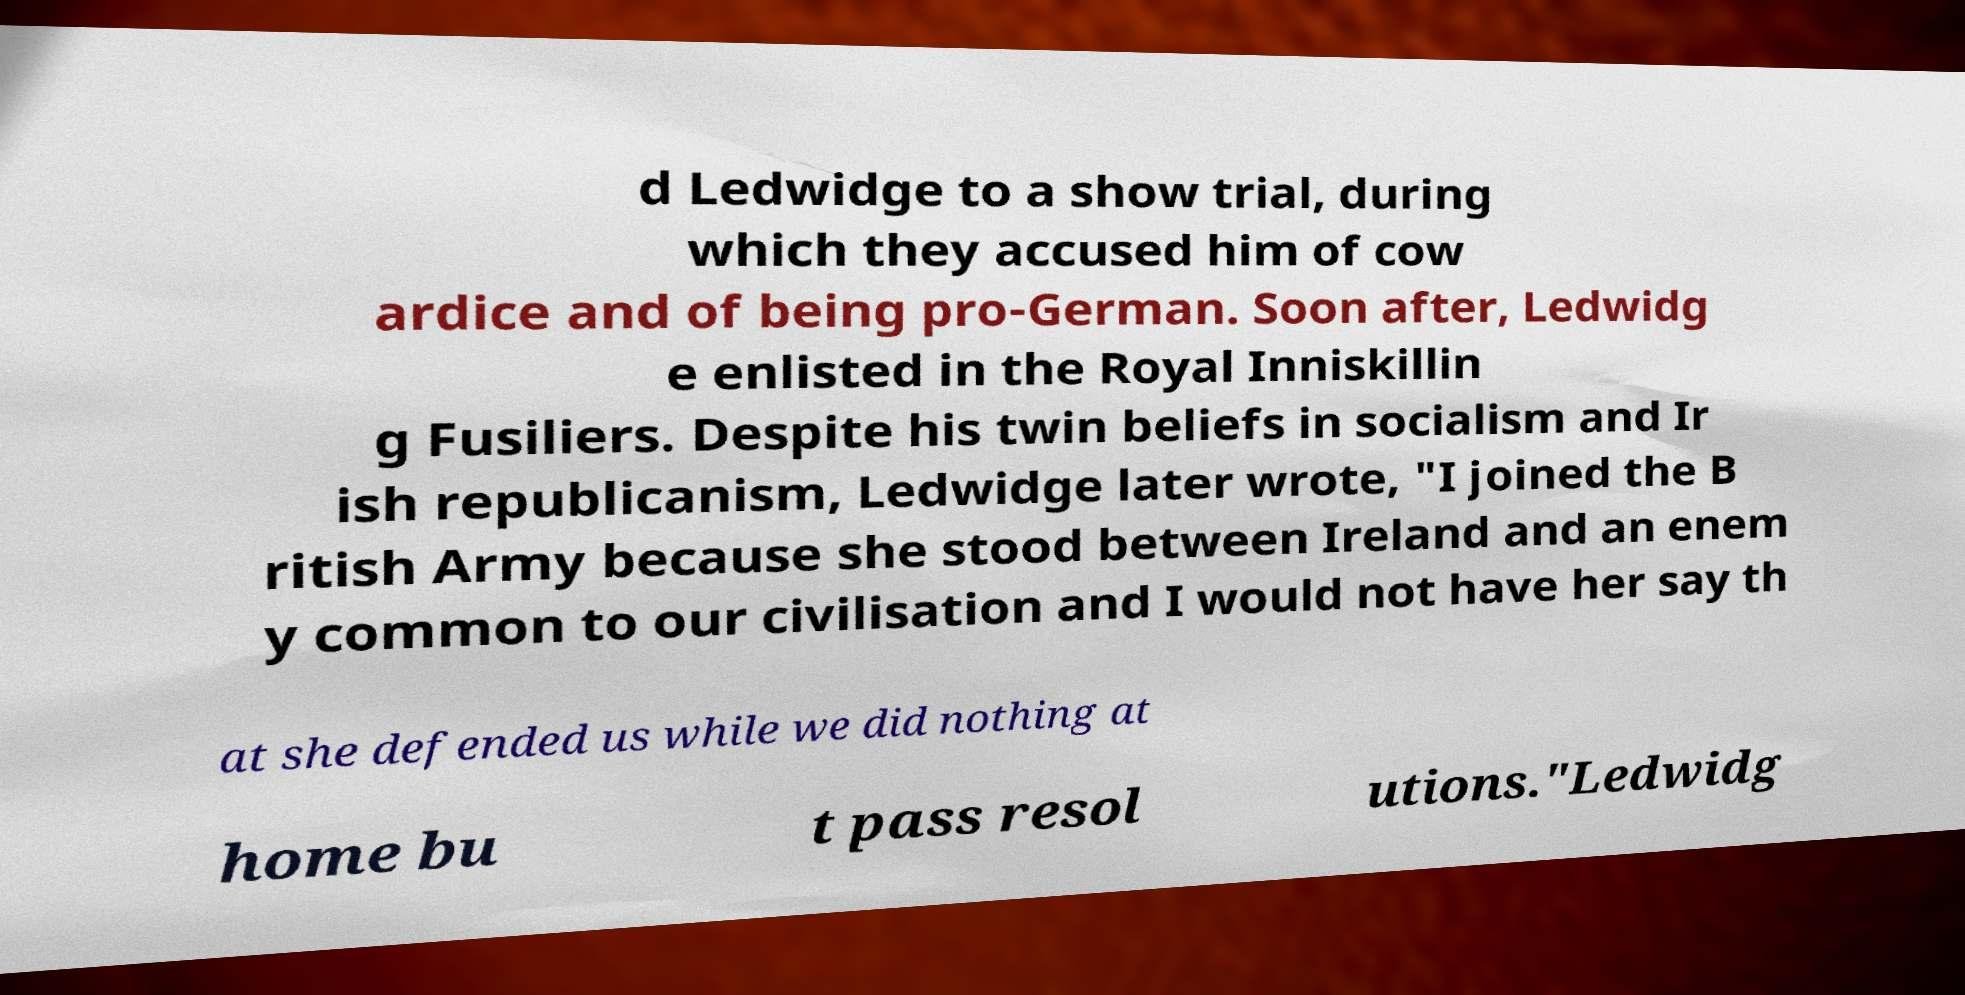Can you read and provide the text displayed in the image?This photo seems to have some interesting text. Can you extract and type it out for me? d Ledwidge to a show trial, during which they accused him of cow ardice and of being pro-German. Soon after, Ledwidg e enlisted in the Royal Inniskillin g Fusiliers. Despite his twin beliefs in socialism and Ir ish republicanism, Ledwidge later wrote, "I joined the B ritish Army because she stood between Ireland and an enem y common to our civilisation and I would not have her say th at she defended us while we did nothing at home bu t pass resol utions."Ledwidg 